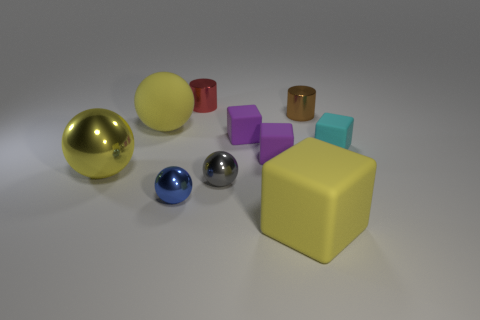What number of cyan rubber blocks have the same size as the gray sphere?
Keep it short and to the point. 1. Are there any purple rubber blocks behind the cube that is behind the cyan object?
Keep it short and to the point. No. How many yellow objects are either metal cylinders or spheres?
Keep it short and to the point. 2. What is the color of the big metallic ball?
Your response must be concise. Yellow. The gray ball that is made of the same material as the red thing is what size?
Your answer should be compact. Small. How many yellow rubber things are the same shape as the cyan rubber object?
Give a very brief answer. 1. Is there any other thing that has the same size as the brown cylinder?
Your answer should be compact. Yes. What is the size of the metallic object to the left of the yellow matte object that is behind the yellow matte block?
Your answer should be compact. Large. What is the material of the cyan cube that is the same size as the gray metal sphere?
Provide a short and direct response. Rubber. Are there any tiny brown objects that have the same material as the blue thing?
Ensure brevity in your answer.  Yes. 